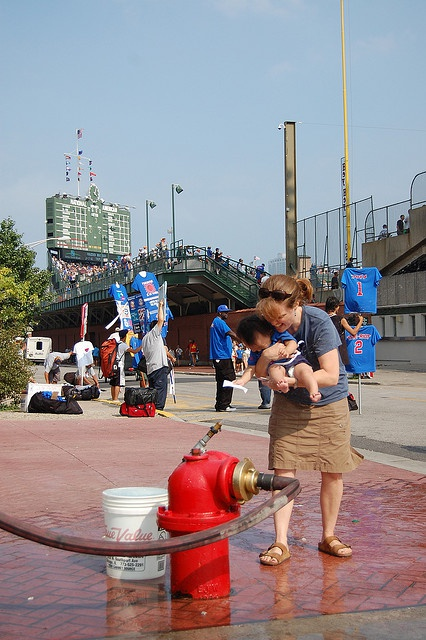Describe the objects in this image and their specific colors. I can see people in lightblue, brown, tan, and maroon tones, fire hydrant in lightblue, red, brown, maroon, and salmon tones, people in lightblue, black, gray, darkgray, and lightgray tones, people in lightblue, black, tan, and brown tones, and people in lightblue, black, navy, and blue tones in this image. 